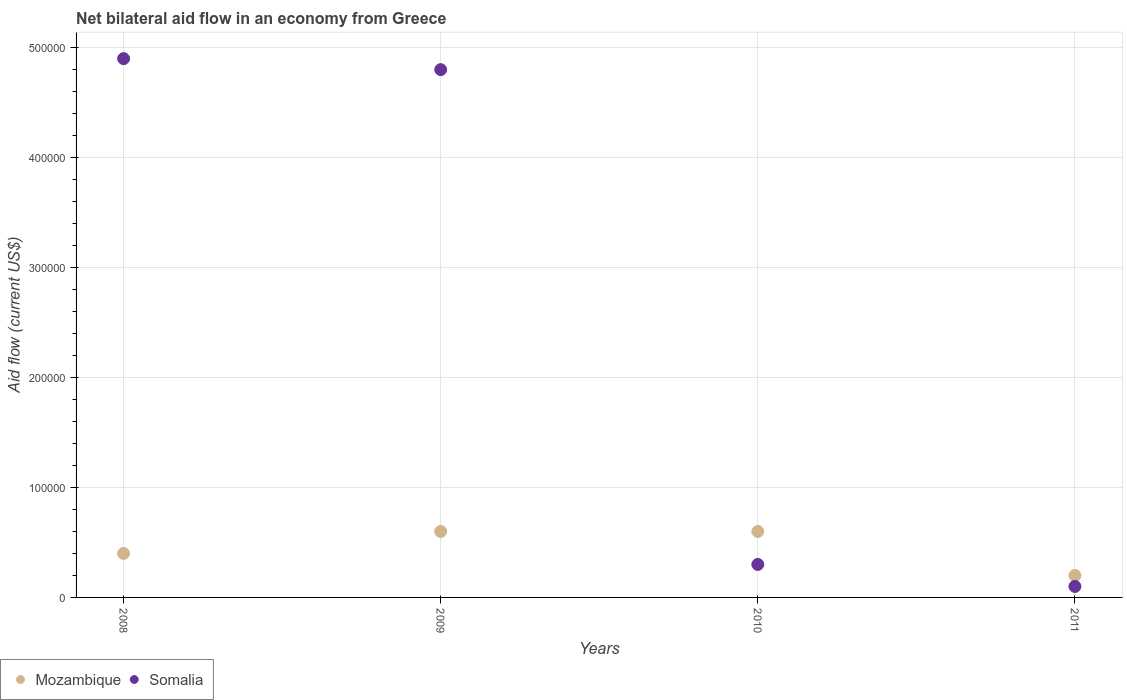Is the number of dotlines equal to the number of legend labels?
Offer a terse response. Yes. What is the net bilateral aid flow in Mozambique in 2010?
Ensure brevity in your answer.  6.00e+04. Across all years, what is the maximum net bilateral aid flow in Somalia?
Ensure brevity in your answer.  4.90e+05. Across all years, what is the minimum net bilateral aid flow in Somalia?
Make the answer very short. 10000. In which year was the net bilateral aid flow in Somalia minimum?
Provide a succinct answer. 2011. What is the total net bilateral aid flow in Somalia in the graph?
Keep it short and to the point. 1.01e+06. What is the difference between the net bilateral aid flow in Somalia in 2008 and that in 2009?
Your answer should be compact. 10000. What is the difference between the net bilateral aid flow in Somalia in 2008 and the net bilateral aid flow in Mozambique in 2009?
Provide a succinct answer. 4.30e+05. What is the average net bilateral aid flow in Mozambique per year?
Give a very brief answer. 4.50e+04. In the year 2010, what is the difference between the net bilateral aid flow in Somalia and net bilateral aid flow in Mozambique?
Ensure brevity in your answer.  -3.00e+04. In how many years, is the net bilateral aid flow in Mozambique greater than 440000 US$?
Keep it short and to the point. 0. What is the ratio of the net bilateral aid flow in Mozambique in 2009 to that in 2010?
Your answer should be compact. 1. Is the net bilateral aid flow in Mozambique in 2008 less than that in 2011?
Offer a terse response. No. Is the difference between the net bilateral aid flow in Somalia in 2008 and 2009 greater than the difference between the net bilateral aid flow in Mozambique in 2008 and 2009?
Ensure brevity in your answer.  Yes. What is the difference between the highest and the second highest net bilateral aid flow in Somalia?
Your answer should be very brief. 10000. What is the difference between the highest and the lowest net bilateral aid flow in Mozambique?
Give a very brief answer. 4.00e+04. In how many years, is the net bilateral aid flow in Somalia greater than the average net bilateral aid flow in Somalia taken over all years?
Give a very brief answer. 2. Is the net bilateral aid flow in Somalia strictly less than the net bilateral aid flow in Mozambique over the years?
Keep it short and to the point. No. What is the difference between two consecutive major ticks on the Y-axis?
Your response must be concise. 1.00e+05. Does the graph contain any zero values?
Offer a very short reply. No. Does the graph contain grids?
Give a very brief answer. Yes. What is the title of the graph?
Offer a terse response. Net bilateral aid flow in an economy from Greece. Does "Macedonia" appear as one of the legend labels in the graph?
Make the answer very short. No. What is the Aid flow (current US$) of Somalia in 2011?
Provide a succinct answer. 10000. Across all years, what is the maximum Aid flow (current US$) in Mozambique?
Make the answer very short. 6.00e+04. Across all years, what is the maximum Aid flow (current US$) in Somalia?
Ensure brevity in your answer.  4.90e+05. Across all years, what is the minimum Aid flow (current US$) of Somalia?
Keep it short and to the point. 10000. What is the total Aid flow (current US$) of Mozambique in the graph?
Provide a short and direct response. 1.80e+05. What is the total Aid flow (current US$) of Somalia in the graph?
Your response must be concise. 1.01e+06. What is the difference between the Aid flow (current US$) in Mozambique in 2008 and that in 2009?
Your response must be concise. -2.00e+04. What is the difference between the Aid flow (current US$) of Somalia in 2008 and that in 2009?
Provide a succinct answer. 10000. What is the difference between the Aid flow (current US$) of Mozambique in 2008 and that in 2010?
Your response must be concise. -2.00e+04. What is the difference between the Aid flow (current US$) of Somalia in 2008 and that in 2010?
Your answer should be very brief. 4.60e+05. What is the difference between the Aid flow (current US$) of Somalia in 2008 and that in 2011?
Your response must be concise. 4.80e+05. What is the difference between the Aid flow (current US$) in Mozambique in 2009 and that in 2011?
Offer a very short reply. 4.00e+04. What is the difference between the Aid flow (current US$) in Somalia in 2009 and that in 2011?
Your answer should be compact. 4.70e+05. What is the difference between the Aid flow (current US$) in Mozambique in 2010 and that in 2011?
Your response must be concise. 4.00e+04. What is the difference between the Aid flow (current US$) of Somalia in 2010 and that in 2011?
Make the answer very short. 2.00e+04. What is the difference between the Aid flow (current US$) of Mozambique in 2008 and the Aid flow (current US$) of Somalia in 2009?
Make the answer very short. -4.40e+05. What is the difference between the Aid flow (current US$) in Mozambique in 2008 and the Aid flow (current US$) in Somalia in 2010?
Provide a succinct answer. 10000. What is the difference between the Aid flow (current US$) in Mozambique in 2009 and the Aid flow (current US$) in Somalia in 2011?
Keep it short and to the point. 5.00e+04. What is the difference between the Aid flow (current US$) of Mozambique in 2010 and the Aid flow (current US$) of Somalia in 2011?
Provide a short and direct response. 5.00e+04. What is the average Aid flow (current US$) of Mozambique per year?
Give a very brief answer. 4.50e+04. What is the average Aid flow (current US$) in Somalia per year?
Offer a very short reply. 2.52e+05. In the year 2008, what is the difference between the Aid flow (current US$) in Mozambique and Aid flow (current US$) in Somalia?
Make the answer very short. -4.50e+05. In the year 2009, what is the difference between the Aid flow (current US$) in Mozambique and Aid flow (current US$) in Somalia?
Provide a short and direct response. -4.20e+05. In the year 2011, what is the difference between the Aid flow (current US$) of Mozambique and Aid flow (current US$) of Somalia?
Give a very brief answer. 10000. What is the ratio of the Aid flow (current US$) in Somalia in 2008 to that in 2009?
Provide a succinct answer. 1.02. What is the ratio of the Aid flow (current US$) of Mozambique in 2008 to that in 2010?
Provide a succinct answer. 0.67. What is the ratio of the Aid flow (current US$) in Somalia in 2008 to that in 2010?
Offer a terse response. 16.33. What is the ratio of the Aid flow (current US$) of Mozambique in 2009 to that in 2010?
Your answer should be very brief. 1. What is the ratio of the Aid flow (current US$) of Somalia in 2009 to that in 2010?
Your answer should be very brief. 16. What is the difference between the highest and the second highest Aid flow (current US$) of Mozambique?
Offer a terse response. 0. What is the difference between the highest and the second highest Aid flow (current US$) in Somalia?
Keep it short and to the point. 10000. 